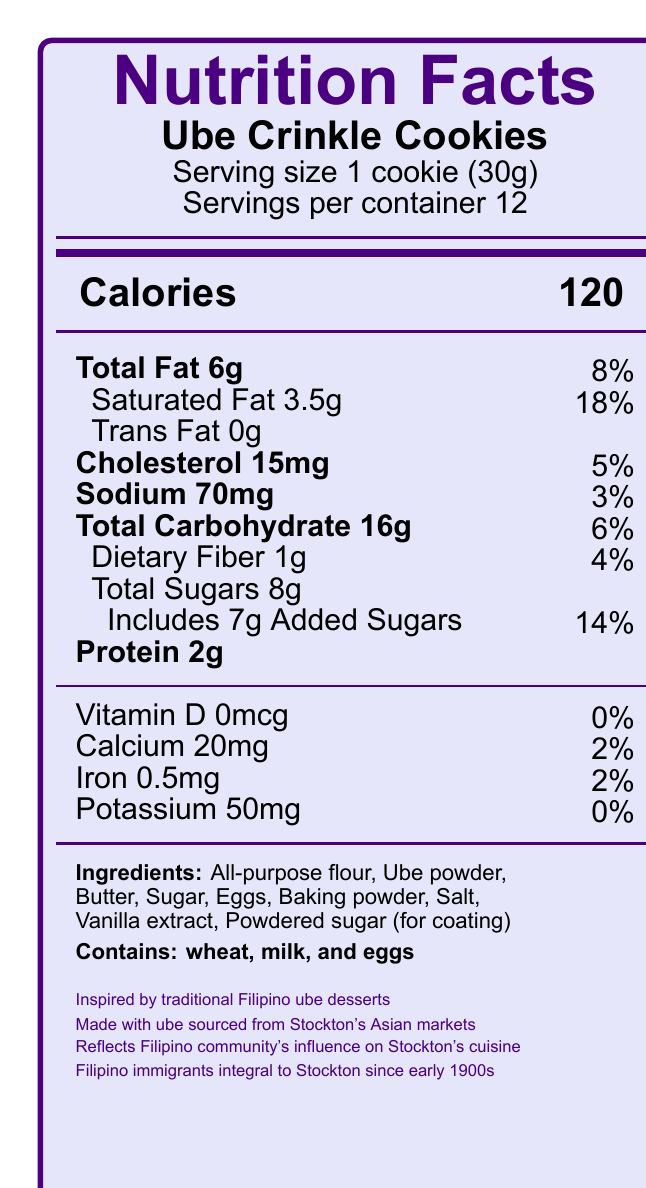how many calories are in one Ube Crinkle Cookie? The document specifies that there are 120 calories per cookie.
Answer: 120 what is the serving size for Ube Crinkle Cookies? The serving size is detailed as 1 cookie (30g) in the document.
Answer: 1 cookie (30g) how much saturated fat is in each serving? The document states that each serving contains 3.5g of saturated fat.
Answer: 3.5g what is the daily value percentage for added sugars? The daily value percentage for added sugars is listed as 14% in the document.
Answer: 14% name three main ingredients in Ube Crinkle Cookies Three of the main ingredients mentioned are all-purpose flour, ube powder, and butter.
Answer: All-purpose flour, Ube powder, Butter which of the following is NOT an allergen in Ube Crinkle Cookies? A. Wheat B. Milk C. Eggs D. Soy The document lists wheat, milk, and eggs as allergens, but not soy.
Answer: D What is the total amount of carbohydrates per serving? The total carbohydrate amount per serving is 16g, according to the document.
Answer: 16g which nutrient has the highest daily value percentage? A. Total Fat B. Saturated Fat C. Cholesterol D. Sodium Saturated Fat has the highest daily value percentage of 18%.
Answer: B do Ube Crinkle Cookies contain trans fat? The document specifies that there is 0g of trans fat.
Answer: No list two pieces of additional information mentioned about the cultural significance of the dessert These details are provided in the "additional info" section of the document.
Answer: Reflects Filipino community's influence on Stockton’s culinary landscape; Filipino immigrants have been integral to Stockton’s history since the early 1900s. summarize the nutritional content and cultural significance of Ube Crinkle Cookies The summary covers the key nutritional facts and underscores the cultural connection and significance as outlined in the document.
Answer: Ube Crinkle Cookies have 120 calories per serving, with notable amounts of total fat, saturated fat, and carbohydrates. They contain essential ingredients and allergens like wheat, milk, and eggs. Culturally, they draw inspiration from traditional Filipino ube desserts and highlight the Filipino community's long-standing influence and history in Stockton, California. how much protein is in each cookie? The document clearly states that there are 2g of protein per serving.
Answer: 2g is there any Vitamin D in Ube Crinkle Cookies? The document states that there is 0mcg of Vitamin D per serving.
Answer: No from where is the ube used in the cookies sourced? The document mentions that the ube is sourced from Stockton’s Asian markets.
Answer: Stockton’s Asian markets what is the historical significance of the Filipino community in Stockton mentioned in the document? The document notes the historical significance of Filipino immigrants being an integral part of Stockton’s history since the early 1900s.
Answer: Filipino immigrants have been an integral part of Stockton's history since the early 1900s. what is the primary source of dietary fiber in Ube Crinkle Cookies? The document lists the amount of dietary fiber but does not specify the primary source of it.
Answer: Cannot be determined 